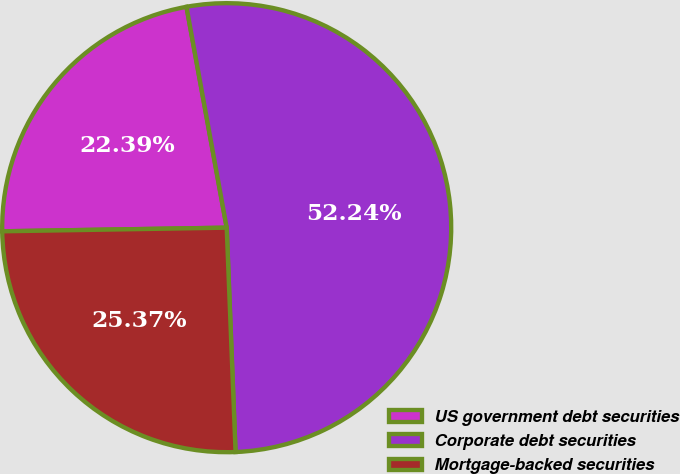Convert chart. <chart><loc_0><loc_0><loc_500><loc_500><pie_chart><fcel>US government debt securities<fcel>Corporate debt securities<fcel>Mortgage-backed securities<nl><fcel>22.39%<fcel>52.24%<fcel>25.37%<nl></chart> 